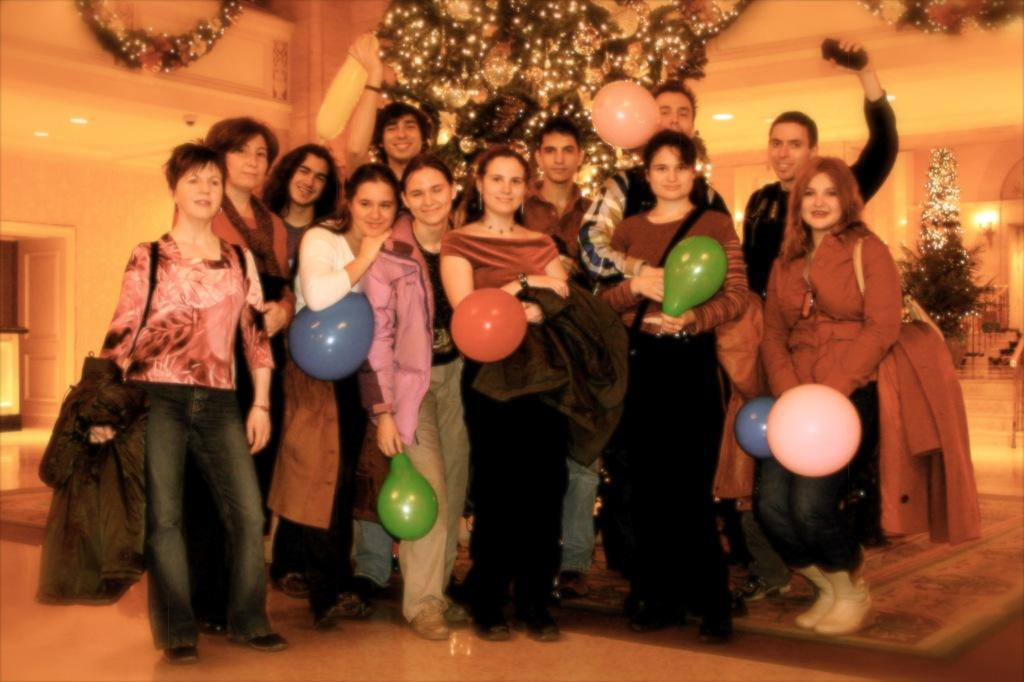How many people are in the image? There is a group of people in the image, but the exact number is not specified. What are some people holding in the image? Some people are holding balloons in the image. What can be seen in the background of the image? There are trees and lights visible in the background of the image. What type of rock can be seen in the image? There is no rock present in the image. How much waste is visible in the image? There is no waste visible in the image. 